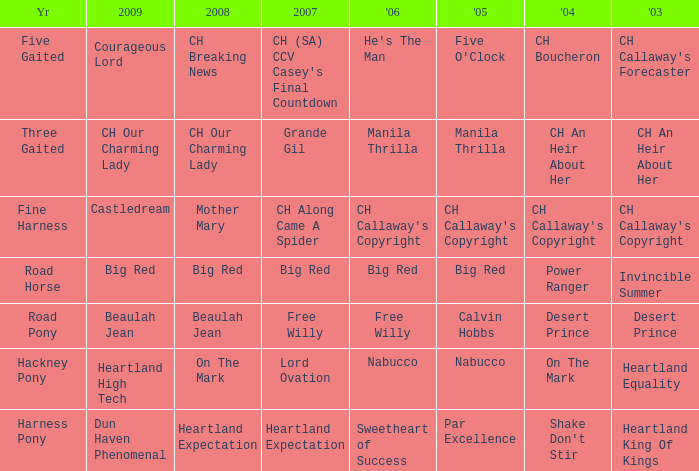What is the 2008 for the 2009 ch our charming lady? CH Our Charming Lady. 